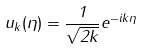<formula> <loc_0><loc_0><loc_500><loc_500>u _ { k } ( \eta ) = \frac { 1 } { \sqrt { 2 k } } e ^ { - i k \eta }</formula> 